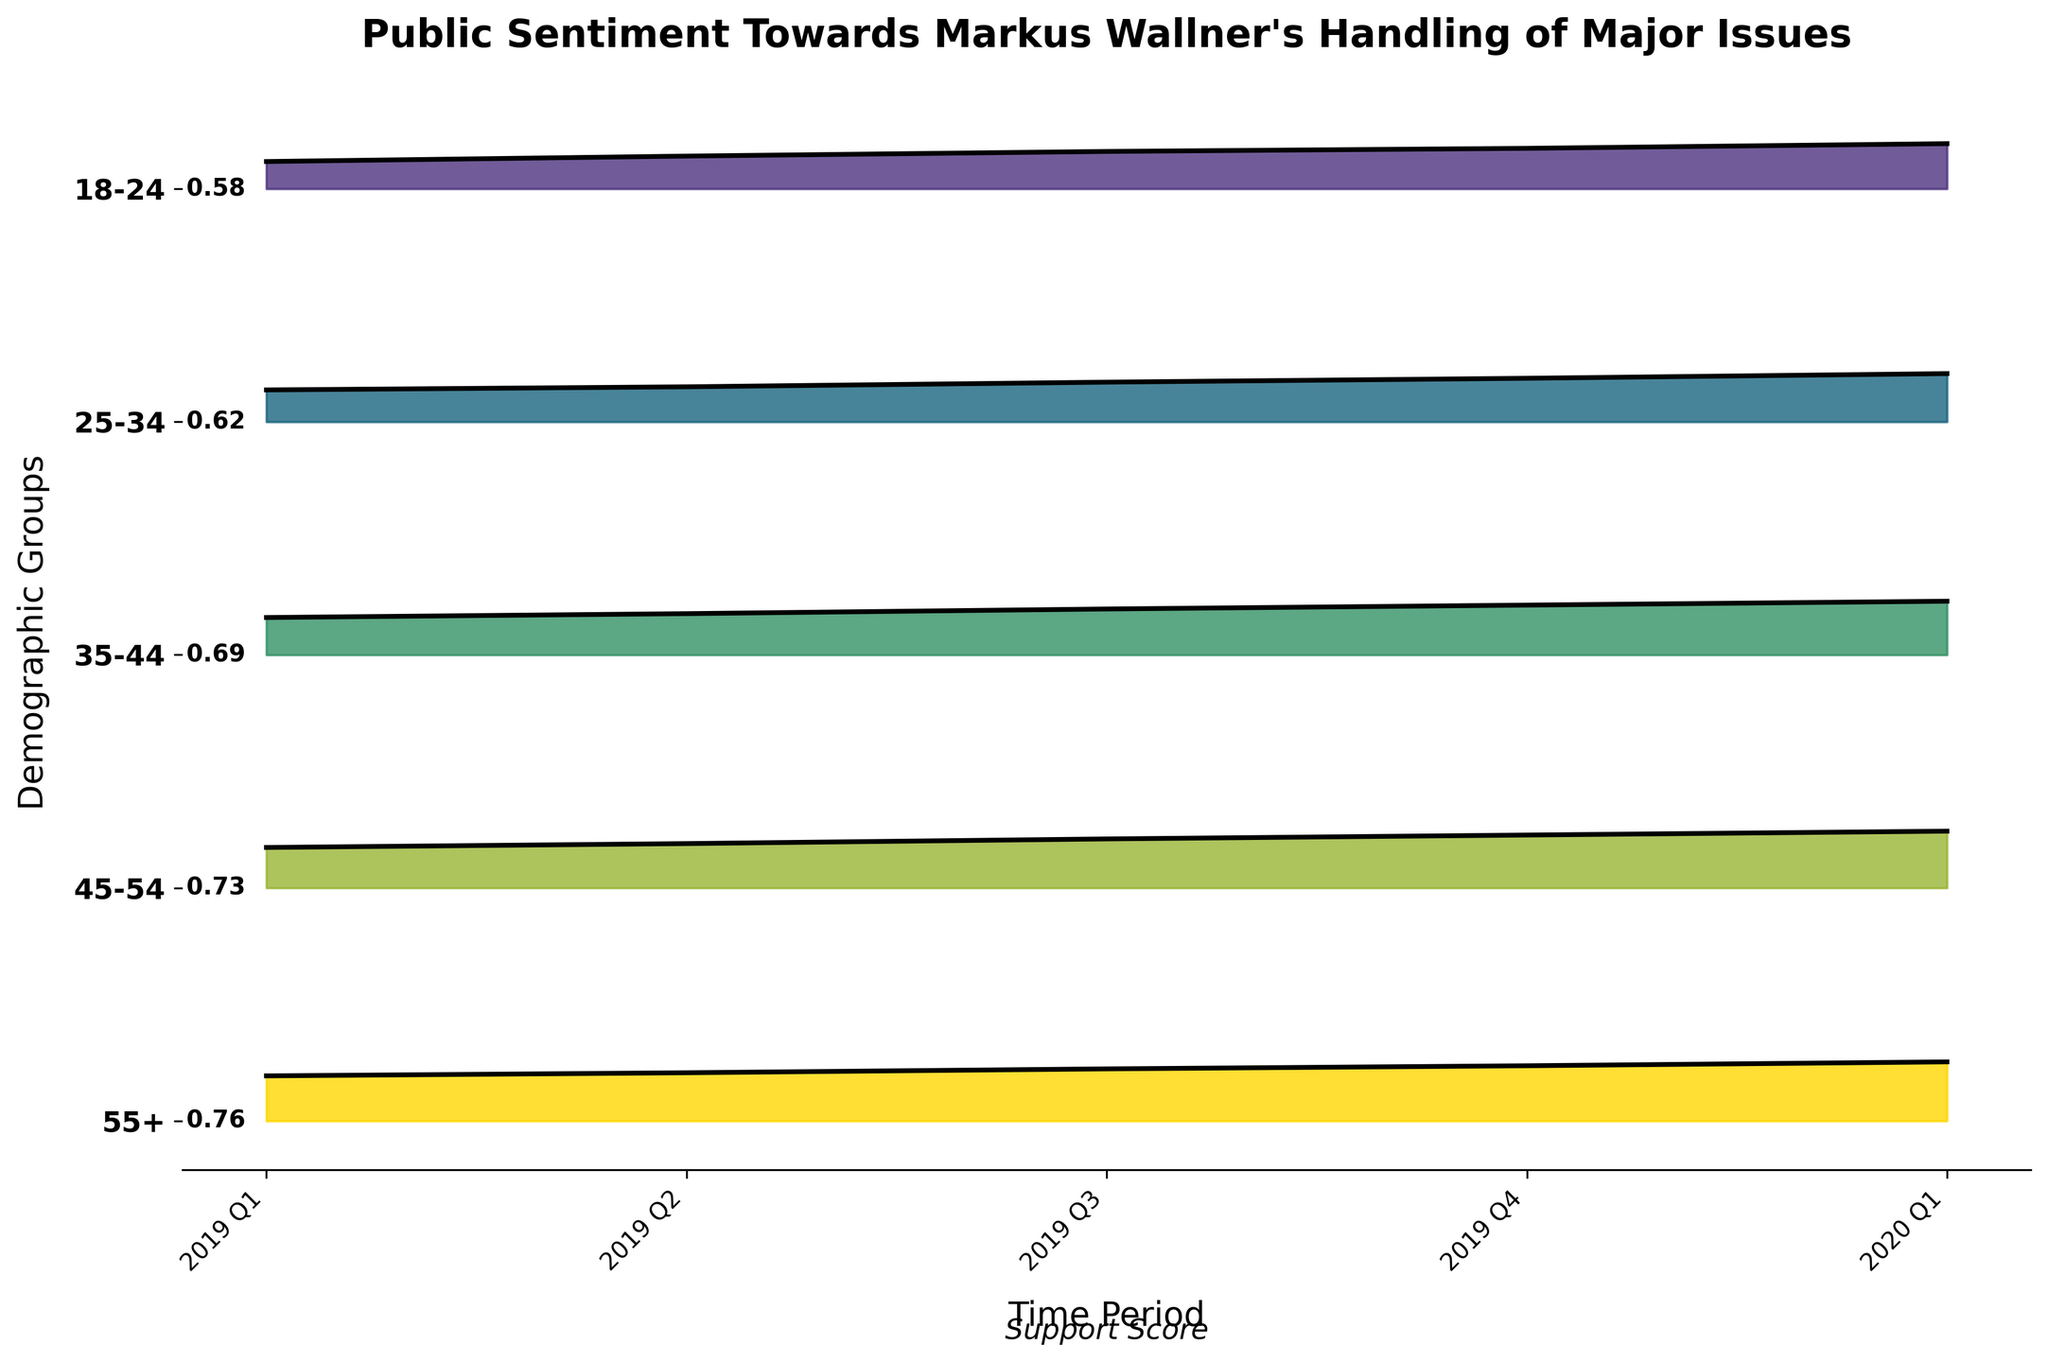Which demographic group has the highest support score in 2020 Q1? By looking at the top of the peaks in the Ridgeline plot for 2020 Q1, we see that the 55+ demographic group has the highest support score.
Answer: 55+ What is the trend of the support score for the 25-34 demographic group from 2019 Q1 to 2020 Q1? Observing the consecutive increases in the peaks for the 25-34 demographic group from 2019 Q1 to 2020 Q1, we identify an upward trend.
Answer: Upward trend How does the support score for the 18-24 age group in 2019 Q4 compare with the 45-54 age group in the same period? Comparing the heights of the peaks for 2019 Q4 shows that the support score for the 45-54 age group is higher than that for the 18-24 age group.
Answer: Higher What is the average support score for all age groups in 2019 Q2? Averaging the support scores across all demographics in 2019 Q2 (0.42 + 0.45 + 0.53 + 0.57 + 0.62)/5 = 0.518.
Answer: 0.518 Which demographic group shows the most improvement in support score from 2019 Q1 to 2020 Q1? Calculating the score differences for each demographic between 2019 Q1 and 2020 Q1: 
18-24: 0.58 - 0.35 = 0.23,
25-34: 0.62 - 0.41 = 0.21,
35-44: 0.69 - 0.48 = 0.21,
45-54: 0.73 - 0.52 = 0.21,
55+: 0.76 - 0.58 = 0.18,
The 18-24 group shows the most improvement.
Answer: 18-24 Which time period exhibits the highest average support score across all demographics? First finding the average support score for each time period:
2019 Q1: (0.35 + 0.41 + 0.48 + 0.52 + 0.58)/5 = 0.468,
2019 Q2: (0.42 + 0.45 + 0.53 + 0.57 + 0.62)/5 = 0.518,
2019 Q3: (0.48 + 0.51 + 0.59 + 0.63 + 0.67)/5 = 0.576,
2019 Q4: (0.52 + 0.56 + 0.64 + 0.68 + 0.71)/5 = 0.622,
2020 Q1: (0.58 + 0.62 + 0.69 + 0.73 + 0.76)/5 = 0.676,
Thus, 2020 Q1 has the highest average support score.
Answer: 2020 Q1 How does the support score trend for the 35-44 demographic change over the time periods presented? Observing the peaks for the 35-44 group, we see a consistent upward trend from 2019 Q1 to 2020 Q1.
Answer: Upward trend What is the difference in support score between the 18-24 and 55+ demographics in 2020 Q1? The support score for the 18-24 group in 2020 Q1 is 0.58 and for the 55+ group is 0.76. The difference is 0.76 - 0.58 = 0.18.
Answer: 0.18 